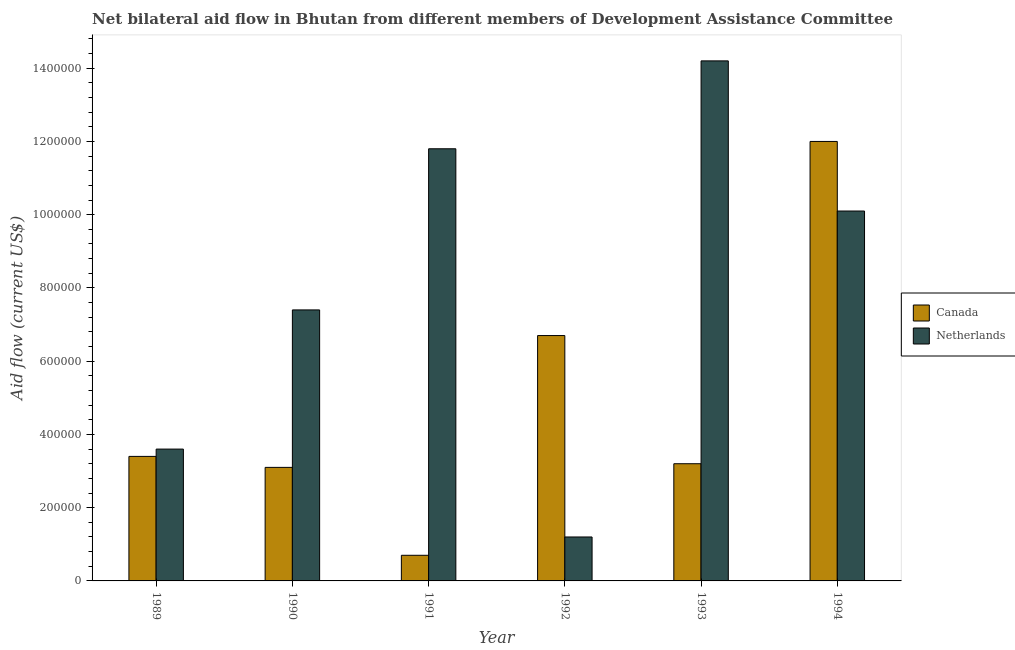How many groups of bars are there?
Keep it short and to the point. 6. Are the number of bars per tick equal to the number of legend labels?
Ensure brevity in your answer.  Yes. How many bars are there on the 5th tick from the left?
Ensure brevity in your answer.  2. How many bars are there on the 1st tick from the right?
Offer a terse response. 2. What is the label of the 5th group of bars from the left?
Offer a very short reply. 1993. In how many cases, is the number of bars for a given year not equal to the number of legend labels?
Provide a short and direct response. 0. What is the amount of aid given by netherlands in 1993?
Make the answer very short. 1.42e+06. Across all years, what is the maximum amount of aid given by canada?
Your response must be concise. 1.20e+06. Across all years, what is the minimum amount of aid given by canada?
Your answer should be very brief. 7.00e+04. In which year was the amount of aid given by canada maximum?
Ensure brevity in your answer.  1994. What is the total amount of aid given by canada in the graph?
Provide a short and direct response. 2.91e+06. What is the difference between the amount of aid given by canada in 1991 and that in 1993?
Your answer should be very brief. -2.50e+05. What is the difference between the amount of aid given by netherlands in 1990 and the amount of aid given by canada in 1989?
Keep it short and to the point. 3.80e+05. What is the average amount of aid given by netherlands per year?
Provide a succinct answer. 8.05e+05. In the year 1990, what is the difference between the amount of aid given by canada and amount of aid given by netherlands?
Ensure brevity in your answer.  0. What is the ratio of the amount of aid given by canada in 1989 to that in 1992?
Ensure brevity in your answer.  0.51. Is the difference between the amount of aid given by canada in 1990 and 1994 greater than the difference between the amount of aid given by netherlands in 1990 and 1994?
Offer a terse response. No. What is the difference between the highest and the lowest amount of aid given by netherlands?
Your answer should be very brief. 1.30e+06. In how many years, is the amount of aid given by netherlands greater than the average amount of aid given by netherlands taken over all years?
Provide a succinct answer. 3. Is the sum of the amount of aid given by canada in 1992 and 1994 greater than the maximum amount of aid given by netherlands across all years?
Keep it short and to the point. Yes. What does the 2nd bar from the right in 1990 represents?
Your response must be concise. Canada. How many bars are there?
Make the answer very short. 12. Are all the bars in the graph horizontal?
Give a very brief answer. No. How many years are there in the graph?
Your response must be concise. 6. What is the difference between two consecutive major ticks on the Y-axis?
Your answer should be compact. 2.00e+05. Are the values on the major ticks of Y-axis written in scientific E-notation?
Your response must be concise. No. Does the graph contain grids?
Provide a short and direct response. No. Where does the legend appear in the graph?
Keep it short and to the point. Center right. What is the title of the graph?
Give a very brief answer. Net bilateral aid flow in Bhutan from different members of Development Assistance Committee. What is the Aid flow (current US$) of Canada in 1989?
Offer a terse response. 3.40e+05. What is the Aid flow (current US$) in Netherlands in 1989?
Offer a terse response. 3.60e+05. What is the Aid flow (current US$) in Canada in 1990?
Keep it short and to the point. 3.10e+05. What is the Aid flow (current US$) of Netherlands in 1990?
Ensure brevity in your answer.  7.40e+05. What is the Aid flow (current US$) in Canada in 1991?
Your answer should be very brief. 7.00e+04. What is the Aid flow (current US$) in Netherlands in 1991?
Your response must be concise. 1.18e+06. What is the Aid flow (current US$) of Canada in 1992?
Your answer should be very brief. 6.70e+05. What is the Aid flow (current US$) of Netherlands in 1993?
Your answer should be compact. 1.42e+06. What is the Aid flow (current US$) of Canada in 1994?
Provide a short and direct response. 1.20e+06. What is the Aid flow (current US$) of Netherlands in 1994?
Provide a succinct answer. 1.01e+06. Across all years, what is the maximum Aid flow (current US$) of Canada?
Your answer should be compact. 1.20e+06. Across all years, what is the maximum Aid flow (current US$) in Netherlands?
Ensure brevity in your answer.  1.42e+06. Across all years, what is the minimum Aid flow (current US$) in Canada?
Keep it short and to the point. 7.00e+04. What is the total Aid flow (current US$) in Canada in the graph?
Make the answer very short. 2.91e+06. What is the total Aid flow (current US$) of Netherlands in the graph?
Offer a very short reply. 4.83e+06. What is the difference between the Aid flow (current US$) of Netherlands in 1989 and that in 1990?
Keep it short and to the point. -3.80e+05. What is the difference between the Aid flow (current US$) in Canada in 1989 and that in 1991?
Ensure brevity in your answer.  2.70e+05. What is the difference between the Aid flow (current US$) in Netherlands in 1989 and that in 1991?
Offer a terse response. -8.20e+05. What is the difference between the Aid flow (current US$) in Canada in 1989 and that in 1992?
Ensure brevity in your answer.  -3.30e+05. What is the difference between the Aid flow (current US$) of Canada in 1989 and that in 1993?
Your answer should be compact. 2.00e+04. What is the difference between the Aid flow (current US$) in Netherlands in 1989 and that in 1993?
Offer a very short reply. -1.06e+06. What is the difference between the Aid flow (current US$) of Canada in 1989 and that in 1994?
Keep it short and to the point. -8.60e+05. What is the difference between the Aid flow (current US$) in Netherlands in 1989 and that in 1994?
Offer a terse response. -6.50e+05. What is the difference between the Aid flow (current US$) in Netherlands in 1990 and that in 1991?
Your answer should be very brief. -4.40e+05. What is the difference between the Aid flow (current US$) of Canada in 1990 and that in 1992?
Your answer should be compact. -3.60e+05. What is the difference between the Aid flow (current US$) in Netherlands in 1990 and that in 1992?
Provide a short and direct response. 6.20e+05. What is the difference between the Aid flow (current US$) of Netherlands in 1990 and that in 1993?
Provide a short and direct response. -6.80e+05. What is the difference between the Aid flow (current US$) of Canada in 1990 and that in 1994?
Give a very brief answer. -8.90e+05. What is the difference between the Aid flow (current US$) of Canada in 1991 and that in 1992?
Ensure brevity in your answer.  -6.00e+05. What is the difference between the Aid flow (current US$) of Netherlands in 1991 and that in 1992?
Provide a short and direct response. 1.06e+06. What is the difference between the Aid flow (current US$) in Canada in 1991 and that in 1994?
Your response must be concise. -1.13e+06. What is the difference between the Aid flow (current US$) of Canada in 1992 and that in 1993?
Your answer should be very brief. 3.50e+05. What is the difference between the Aid flow (current US$) in Netherlands in 1992 and that in 1993?
Offer a very short reply. -1.30e+06. What is the difference between the Aid flow (current US$) in Canada in 1992 and that in 1994?
Provide a succinct answer. -5.30e+05. What is the difference between the Aid flow (current US$) in Netherlands in 1992 and that in 1994?
Make the answer very short. -8.90e+05. What is the difference between the Aid flow (current US$) of Canada in 1993 and that in 1994?
Make the answer very short. -8.80e+05. What is the difference between the Aid flow (current US$) in Canada in 1989 and the Aid flow (current US$) in Netherlands in 1990?
Give a very brief answer. -4.00e+05. What is the difference between the Aid flow (current US$) of Canada in 1989 and the Aid flow (current US$) of Netherlands in 1991?
Your answer should be compact. -8.40e+05. What is the difference between the Aid flow (current US$) of Canada in 1989 and the Aid flow (current US$) of Netherlands in 1992?
Ensure brevity in your answer.  2.20e+05. What is the difference between the Aid flow (current US$) of Canada in 1989 and the Aid flow (current US$) of Netherlands in 1993?
Your answer should be very brief. -1.08e+06. What is the difference between the Aid flow (current US$) of Canada in 1989 and the Aid flow (current US$) of Netherlands in 1994?
Offer a very short reply. -6.70e+05. What is the difference between the Aid flow (current US$) of Canada in 1990 and the Aid flow (current US$) of Netherlands in 1991?
Provide a short and direct response. -8.70e+05. What is the difference between the Aid flow (current US$) of Canada in 1990 and the Aid flow (current US$) of Netherlands in 1992?
Offer a terse response. 1.90e+05. What is the difference between the Aid flow (current US$) of Canada in 1990 and the Aid flow (current US$) of Netherlands in 1993?
Ensure brevity in your answer.  -1.11e+06. What is the difference between the Aid flow (current US$) in Canada in 1990 and the Aid flow (current US$) in Netherlands in 1994?
Offer a terse response. -7.00e+05. What is the difference between the Aid flow (current US$) of Canada in 1991 and the Aid flow (current US$) of Netherlands in 1992?
Keep it short and to the point. -5.00e+04. What is the difference between the Aid flow (current US$) of Canada in 1991 and the Aid flow (current US$) of Netherlands in 1993?
Your response must be concise. -1.35e+06. What is the difference between the Aid flow (current US$) in Canada in 1991 and the Aid flow (current US$) in Netherlands in 1994?
Offer a terse response. -9.40e+05. What is the difference between the Aid flow (current US$) in Canada in 1992 and the Aid flow (current US$) in Netherlands in 1993?
Give a very brief answer. -7.50e+05. What is the difference between the Aid flow (current US$) in Canada in 1993 and the Aid flow (current US$) in Netherlands in 1994?
Your answer should be compact. -6.90e+05. What is the average Aid flow (current US$) of Canada per year?
Offer a very short reply. 4.85e+05. What is the average Aid flow (current US$) in Netherlands per year?
Your response must be concise. 8.05e+05. In the year 1989, what is the difference between the Aid flow (current US$) of Canada and Aid flow (current US$) of Netherlands?
Your answer should be very brief. -2.00e+04. In the year 1990, what is the difference between the Aid flow (current US$) of Canada and Aid flow (current US$) of Netherlands?
Your answer should be compact. -4.30e+05. In the year 1991, what is the difference between the Aid flow (current US$) in Canada and Aid flow (current US$) in Netherlands?
Ensure brevity in your answer.  -1.11e+06. In the year 1993, what is the difference between the Aid flow (current US$) of Canada and Aid flow (current US$) of Netherlands?
Provide a succinct answer. -1.10e+06. What is the ratio of the Aid flow (current US$) in Canada in 1989 to that in 1990?
Offer a terse response. 1.1. What is the ratio of the Aid flow (current US$) of Netherlands in 1989 to that in 1990?
Your answer should be very brief. 0.49. What is the ratio of the Aid flow (current US$) in Canada in 1989 to that in 1991?
Provide a succinct answer. 4.86. What is the ratio of the Aid flow (current US$) of Netherlands in 1989 to that in 1991?
Ensure brevity in your answer.  0.31. What is the ratio of the Aid flow (current US$) in Canada in 1989 to that in 1992?
Your answer should be very brief. 0.51. What is the ratio of the Aid flow (current US$) in Netherlands in 1989 to that in 1992?
Offer a terse response. 3. What is the ratio of the Aid flow (current US$) in Netherlands in 1989 to that in 1993?
Provide a short and direct response. 0.25. What is the ratio of the Aid flow (current US$) of Canada in 1989 to that in 1994?
Your answer should be compact. 0.28. What is the ratio of the Aid flow (current US$) in Netherlands in 1989 to that in 1994?
Your answer should be compact. 0.36. What is the ratio of the Aid flow (current US$) of Canada in 1990 to that in 1991?
Make the answer very short. 4.43. What is the ratio of the Aid flow (current US$) in Netherlands in 1990 to that in 1991?
Your answer should be very brief. 0.63. What is the ratio of the Aid flow (current US$) of Canada in 1990 to that in 1992?
Give a very brief answer. 0.46. What is the ratio of the Aid flow (current US$) of Netherlands in 1990 to that in 1992?
Provide a succinct answer. 6.17. What is the ratio of the Aid flow (current US$) of Canada in 1990 to that in 1993?
Keep it short and to the point. 0.97. What is the ratio of the Aid flow (current US$) in Netherlands in 1990 to that in 1993?
Ensure brevity in your answer.  0.52. What is the ratio of the Aid flow (current US$) in Canada in 1990 to that in 1994?
Your response must be concise. 0.26. What is the ratio of the Aid flow (current US$) of Netherlands in 1990 to that in 1994?
Give a very brief answer. 0.73. What is the ratio of the Aid flow (current US$) in Canada in 1991 to that in 1992?
Your answer should be very brief. 0.1. What is the ratio of the Aid flow (current US$) in Netherlands in 1991 to that in 1992?
Keep it short and to the point. 9.83. What is the ratio of the Aid flow (current US$) of Canada in 1991 to that in 1993?
Keep it short and to the point. 0.22. What is the ratio of the Aid flow (current US$) in Netherlands in 1991 to that in 1993?
Your answer should be very brief. 0.83. What is the ratio of the Aid flow (current US$) in Canada in 1991 to that in 1994?
Give a very brief answer. 0.06. What is the ratio of the Aid flow (current US$) of Netherlands in 1991 to that in 1994?
Keep it short and to the point. 1.17. What is the ratio of the Aid flow (current US$) of Canada in 1992 to that in 1993?
Your answer should be very brief. 2.09. What is the ratio of the Aid flow (current US$) in Netherlands in 1992 to that in 1993?
Keep it short and to the point. 0.08. What is the ratio of the Aid flow (current US$) of Canada in 1992 to that in 1994?
Provide a short and direct response. 0.56. What is the ratio of the Aid flow (current US$) in Netherlands in 1992 to that in 1994?
Your answer should be very brief. 0.12. What is the ratio of the Aid flow (current US$) of Canada in 1993 to that in 1994?
Provide a short and direct response. 0.27. What is the ratio of the Aid flow (current US$) in Netherlands in 1993 to that in 1994?
Make the answer very short. 1.41. What is the difference between the highest and the second highest Aid flow (current US$) in Canada?
Ensure brevity in your answer.  5.30e+05. What is the difference between the highest and the lowest Aid flow (current US$) of Canada?
Keep it short and to the point. 1.13e+06. What is the difference between the highest and the lowest Aid flow (current US$) in Netherlands?
Provide a short and direct response. 1.30e+06. 